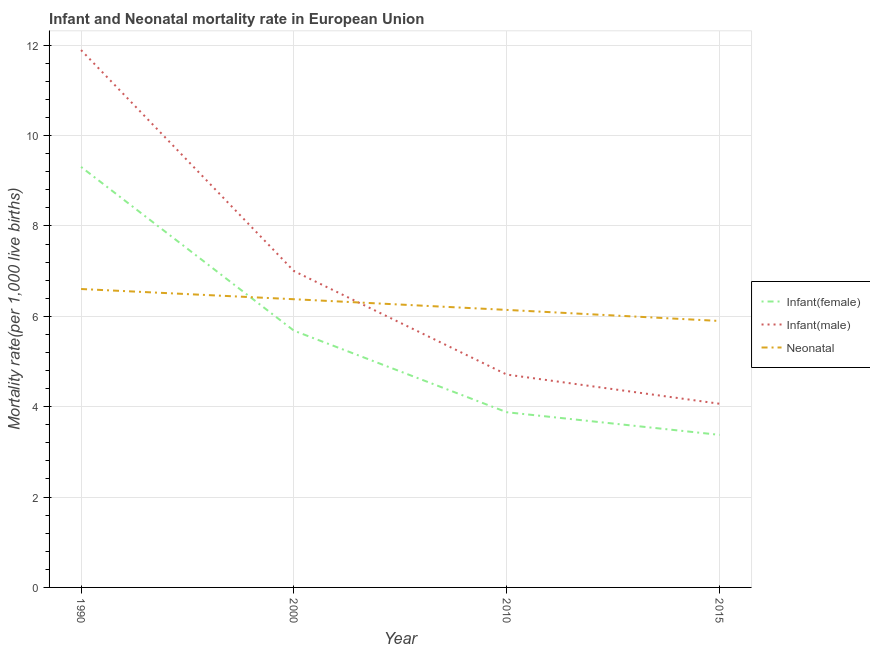Does the line corresponding to infant mortality rate(female) intersect with the line corresponding to neonatal mortality rate?
Offer a very short reply. Yes. Is the number of lines equal to the number of legend labels?
Keep it short and to the point. Yes. What is the neonatal mortality rate in 2015?
Your answer should be very brief. 5.9. Across all years, what is the maximum infant mortality rate(male)?
Your response must be concise. 11.89. Across all years, what is the minimum infant mortality rate(female)?
Offer a very short reply. 3.38. In which year was the infant mortality rate(male) minimum?
Offer a terse response. 2015. What is the total infant mortality rate(male) in the graph?
Ensure brevity in your answer.  27.67. What is the difference between the infant mortality rate(female) in 1990 and that in 2010?
Your answer should be compact. 5.43. What is the difference between the neonatal mortality rate in 2015 and the infant mortality rate(female) in 1990?
Your answer should be compact. -3.41. What is the average infant mortality rate(male) per year?
Give a very brief answer. 6.92. In the year 2000, what is the difference between the neonatal mortality rate and infant mortality rate(male)?
Ensure brevity in your answer.  -0.62. In how many years, is the neonatal mortality rate greater than 2.8?
Offer a terse response. 4. What is the ratio of the infant mortality rate(male) in 2010 to that in 2015?
Your response must be concise. 1.16. Is the difference between the infant mortality rate(male) in 2010 and 2015 greater than the difference between the infant mortality rate(female) in 2010 and 2015?
Your answer should be compact. Yes. What is the difference between the highest and the second highest infant mortality rate(male)?
Keep it short and to the point. 4.89. What is the difference between the highest and the lowest neonatal mortality rate?
Your answer should be compact. 0.71. Is the sum of the neonatal mortality rate in 2000 and 2010 greater than the maximum infant mortality rate(male) across all years?
Offer a very short reply. Yes. Does the infant mortality rate(male) monotonically increase over the years?
Offer a terse response. No. How many lines are there?
Make the answer very short. 3. How many years are there in the graph?
Give a very brief answer. 4. Does the graph contain any zero values?
Provide a succinct answer. No. Where does the legend appear in the graph?
Your answer should be very brief. Center right. How many legend labels are there?
Offer a terse response. 3. What is the title of the graph?
Your answer should be compact. Infant and Neonatal mortality rate in European Union. What is the label or title of the X-axis?
Ensure brevity in your answer.  Year. What is the label or title of the Y-axis?
Your answer should be very brief. Mortality rate(per 1,0 live births). What is the Mortality rate(per 1,000 live births) in Infant(female) in 1990?
Your answer should be compact. 9.31. What is the Mortality rate(per 1,000 live births) in Infant(male) in 1990?
Your answer should be very brief. 11.89. What is the Mortality rate(per 1,000 live births) in Neonatal  in 1990?
Make the answer very short. 6.6. What is the Mortality rate(per 1,000 live births) in Infant(female) in 2000?
Your response must be concise. 5.68. What is the Mortality rate(per 1,000 live births) of Infant(male) in 2000?
Offer a very short reply. 7. What is the Mortality rate(per 1,000 live births) in Neonatal  in 2000?
Ensure brevity in your answer.  6.38. What is the Mortality rate(per 1,000 live births) in Infant(female) in 2010?
Offer a very short reply. 3.88. What is the Mortality rate(per 1,000 live births) of Infant(male) in 2010?
Keep it short and to the point. 4.71. What is the Mortality rate(per 1,000 live births) of Neonatal  in 2010?
Ensure brevity in your answer.  6.14. What is the Mortality rate(per 1,000 live births) of Infant(female) in 2015?
Ensure brevity in your answer.  3.38. What is the Mortality rate(per 1,000 live births) of Infant(male) in 2015?
Offer a very short reply. 4.07. What is the Mortality rate(per 1,000 live births) in Neonatal  in 2015?
Ensure brevity in your answer.  5.9. Across all years, what is the maximum Mortality rate(per 1,000 live births) in Infant(female)?
Provide a short and direct response. 9.31. Across all years, what is the maximum Mortality rate(per 1,000 live births) in Infant(male)?
Give a very brief answer. 11.89. Across all years, what is the maximum Mortality rate(per 1,000 live births) of Neonatal ?
Offer a terse response. 6.6. Across all years, what is the minimum Mortality rate(per 1,000 live births) of Infant(female)?
Your answer should be compact. 3.38. Across all years, what is the minimum Mortality rate(per 1,000 live births) in Infant(male)?
Make the answer very short. 4.07. Across all years, what is the minimum Mortality rate(per 1,000 live births) of Neonatal ?
Offer a very short reply. 5.9. What is the total Mortality rate(per 1,000 live births) in Infant(female) in the graph?
Make the answer very short. 22.24. What is the total Mortality rate(per 1,000 live births) of Infant(male) in the graph?
Ensure brevity in your answer.  27.67. What is the total Mortality rate(per 1,000 live births) of Neonatal  in the graph?
Give a very brief answer. 25.02. What is the difference between the Mortality rate(per 1,000 live births) of Infant(female) in 1990 and that in 2000?
Your response must be concise. 3.62. What is the difference between the Mortality rate(per 1,000 live births) in Infant(male) in 1990 and that in 2000?
Your answer should be very brief. 4.89. What is the difference between the Mortality rate(per 1,000 live births) in Neonatal  in 1990 and that in 2000?
Offer a terse response. 0.23. What is the difference between the Mortality rate(per 1,000 live births) of Infant(female) in 1990 and that in 2010?
Give a very brief answer. 5.43. What is the difference between the Mortality rate(per 1,000 live births) in Infant(male) in 1990 and that in 2010?
Keep it short and to the point. 7.18. What is the difference between the Mortality rate(per 1,000 live births) in Neonatal  in 1990 and that in 2010?
Your answer should be compact. 0.46. What is the difference between the Mortality rate(per 1,000 live births) of Infant(female) in 1990 and that in 2015?
Your answer should be very brief. 5.93. What is the difference between the Mortality rate(per 1,000 live births) in Infant(male) in 1990 and that in 2015?
Give a very brief answer. 7.83. What is the difference between the Mortality rate(per 1,000 live births) in Neonatal  in 1990 and that in 2015?
Give a very brief answer. 0.71. What is the difference between the Mortality rate(per 1,000 live births) of Infant(female) in 2000 and that in 2010?
Keep it short and to the point. 1.81. What is the difference between the Mortality rate(per 1,000 live births) of Infant(male) in 2000 and that in 2010?
Make the answer very short. 2.29. What is the difference between the Mortality rate(per 1,000 live births) in Neonatal  in 2000 and that in 2010?
Provide a short and direct response. 0.24. What is the difference between the Mortality rate(per 1,000 live births) of Infant(female) in 2000 and that in 2015?
Give a very brief answer. 2.31. What is the difference between the Mortality rate(per 1,000 live births) of Infant(male) in 2000 and that in 2015?
Provide a succinct answer. 2.94. What is the difference between the Mortality rate(per 1,000 live births) in Neonatal  in 2000 and that in 2015?
Give a very brief answer. 0.48. What is the difference between the Mortality rate(per 1,000 live births) in Infant(female) in 2010 and that in 2015?
Keep it short and to the point. 0.5. What is the difference between the Mortality rate(per 1,000 live births) of Infant(male) in 2010 and that in 2015?
Provide a succinct answer. 0.65. What is the difference between the Mortality rate(per 1,000 live births) of Neonatal  in 2010 and that in 2015?
Offer a very short reply. 0.24. What is the difference between the Mortality rate(per 1,000 live births) in Infant(female) in 1990 and the Mortality rate(per 1,000 live births) in Infant(male) in 2000?
Your answer should be very brief. 2.3. What is the difference between the Mortality rate(per 1,000 live births) in Infant(female) in 1990 and the Mortality rate(per 1,000 live births) in Neonatal  in 2000?
Keep it short and to the point. 2.93. What is the difference between the Mortality rate(per 1,000 live births) of Infant(male) in 1990 and the Mortality rate(per 1,000 live births) of Neonatal  in 2000?
Provide a succinct answer. 5.51. What is the difference between the Mortality rate(per 1,000 live births) of Infant(female) in 1990 and the Mortality rate(per 1,000 live births) of Infant(male) in 2010?
Provide a short and direct response. 4.6. What is the difference between the Mortality rate(per 1,000 live births) of Infant(female) in 1990 and the Mortality rate(per 1,000 live births) of Neonatal  in 2010?
Your response must be concise. 3.16. What is the difference between the Mortality rate(per 1,000 live births) of Infant(male) in 1990 and the Mortality rate(per 1,000 live births) of Neonatal  in 2010?
Your answer should be compact. 5.75. What is the difference between the Mortality rate(per 1,000 live births) of Infant(female) in 1990 and the Mortality rate(per 1,000 live births) of Infant(male) in 2015?
Provide a succinct answer. 5.24. What is the difference between the Mortality rate(per 1,000 live births) of Infant(female) in 1990 and the Mortality rate(per 1,000 live births) of Neonatal  in 2015?
Offer a terse response. 3.41. What is the difference between the Mortality rate(per 1,000 live births) of Infant(male) in 1990 and the Mortality rate(per 1,000 live births) of Neonatal  in 2015?
Provide a succinct answer. 6. What is the difference between the Mortality rate(per 1,000 live births) of Infant(female) in 2000 and the Mortality rate(per 1,000 live births) of Infant(male) in 2010?
Your answer should be very brief. 0.97. What is the difference between the Mortality rate(per 1,000 live births) in Infant(female) in 2000 and the Mortality rate(per 1,000 live births) in Neonatal  in 2010?
Offer a terse response. -0.46. What is the difference between the Mortality rate(per 1,000 live births) in Infant(male) in 2000 and the Mortality rate(per 1,000 live births) in Neonatal  in 2010?
Your response must be concise. 0.86. What is the difference between the Mortality rate(per 1,000 live births) in Infant(female) in 2000 and the Mortality rate(per 1,000 live births) in Infant(male) in 2015?
Offer a terse response. 1.62. What is the difference between the Mortality rate(per 1,000 live births) of Infant(female) in 2000 and the Mortality rate(per 1,000 live births) of Neonatal  in 2015?
Your answer should be very brief. -0.21. What is the difference between the Mortality rate(per 1,000 live births) in Infant(male) in 2000 and the Mortality rate(per 1,000 live births) in Neonatal  in 2015?
Give a very brief answer. 1.1. What is the difference between the Mortality rate(per 1,000 live births) of Infant(female) in 2010 and the Mortality rate(per 1,000 live births) of Infant(male) in 2015?
Offer a terse response. -0.19. What is the difference between the Mortality rate(per 1,000 live births) of Infant(female) in 2010 and the Mortality rate(per 1,000 live births) of Neonatal  in 2015?
Make the answer very short. -2.02. What is the difference between the Mortality rate(per 1,000 live births) of Infant(male) in 2010 and the Mortality rate(per 1,000 live births) of Neonatal  in 2015?
Ensure brevity in your answer.  -1.19. What is the average Mortality rate(per 1,000 live births) in Infant(female) per year?
Provide a short and direct response. 5.56. What is the average Mortality rate(per 1,000 live births) of Infant(male) per year?
Your response must be concise. 6.92. What is the average Mortality rate(per 1,000 live births) in Neonatal  per year?
Provide a short and direct response. 6.26. In the year 1990, what is the difference between the Mortality rate(per 1,000 live births) of Infant(female) and Mortality rate(per 1,000 live births) of Infant(male)?
Offer a terse response. -2.59. In the year 1990, what is the difference between the Mortality rate(per 1,000 live births) of Infant(female) and Mortality rate(per 1,000 live births) of Neonatal ?
Your answer should be very brief. 2.7. In the year 1990, what is the difference between the Mortality rate(per 1,000 live births) in Infant(male) and Mortality rate(per 1,000 live births) in Neonatal ?
Ensure brevity in your answer.  5.29. In the year 2000, what is the difference between the Mortality rate(per 1,000 live births) in Infant(female) and Mortality rate(per 1,000 live births) in Infant(male)?
Make the answer very short. -1.32. In the year 2000, what is the difference between the Mortality rate(per 1,000 live births) in Infant(female) and Mortality rate(per 1,000 live births) in Neonatal ?
Provide a short and direct response. -0.7. In the year 2000, what is the difference between the Mortality rate(per 1,000 live births) of Infant(male) and Mortality rate(per 1,000 live births) of Neonatal ?
Make the answer very short. 0.62. In the year 2010, what is the difference between the Mortality rate(per 1,000 live births) of Infant(female) and Mortality rate(per 1,000 live births) of Infant(male)?
Keep it short and to the point. -0.83. In the year 2010, what is the difference between the Mortality rate(per 1,000 live births) in Infant(female) and Mortality rate(per 1,000 live births) in Neonatal ?
Provide a succinct answer. -2.26. In the year 2010, what is the difference between the Mortality rate(per 1,000 live births) of Infant(male) and Mortality rate(per 1,000 live births) of Neonatal ?
Keep it short and to the point. -1.43. In the year 2015, what is the difference between the Mortality rate(per 1,000 live births) in Infant(female) and Mortality rate(per 1,000 live births) in Infant(male)?
Provide a succinct answer. -0.69. In the year 2015, what is the difference between the Mortality rate(per 1,000 live births) of Infant(female) and Mortality rate(per 1,000 live births) of Neonatal ?
Offer a very short reply. -2.52. In the year 2015, what is the difference between the Mortality rate(per 1,000 live births) of Infant(male) and Mortality rate(per 1,000 live births) of Neonatal ?
Your answer should be very brief. -1.83. What is the ratio of the Mortality rate(per 1,000 live births) of Infant(female) in 1990 to that in 2000?
Your answer should be compact. 1.64. What is the ratio of the Mortality rate(per 1,000 live births) in Infant(male) in 1990 to that in 2000?
Your answer should be compact. 1.7. What is the ratio of the Mortality rate(per 1,000 live births) of Neonatal  in 1990 to that in 2000?
Your response must be concise. 1.04. What is the ratio of the Mortality rate(per 1,000 live births) of Infant(female) in 1990 to that in 2010?
Ensure brevity in your answer.  2.4. What is the ratio of the Mortality rate(per 1,000 live births) of Infant(male) in 1990 to that in 2010?
Offer a very short reply. 2.52. What is the ratio of the Mortality rate(per 1,000 live births) in Neonatal  in 1990 to that in 2010?
Provide a short and direct response. 1.08. What is the ratio of the Mortality rate(per 1,000 live births) of Infant(female) in 1990 to that in 2015?
Your response must be concise. 2.76. What is the ratio of the Mortality rate(per 1,000 live births) of Infant(male) in 1990 to that in 2015?
Provide a short and direct response. 2.93. What is the ratio of the Mortality rate(per 1,000 live births) of Neonatal  in 1990 to that in 2015?
Provide a short and direct response. 1.12. What is the ratio of the Mortality rate(per 1,000 live births) of Infant(female) in 2000 to that in 2010?
Provide a succinct answer. 1.47. What is the ratio of the Mortality rate(per 1,000 live births) of Infant(male) in 2000 to that in 2010?
Offer a very short reply. 1.49. What is the ratio of the Mortality rate(per 1,000 live births) in Neonatal  in 2000 to that in 2010?
Your answer should be compact. 1.04. What is the ratio of the Mortality rate(per 1,000 live births) of Infant(female) in 2000 to that in 2015?
Your response must be concise. 1.68. What is the ratio of the Mortality rate(per 1,000 live births) of Infant(male) in 2000 to that in 2015?
Offer a very short reply. 1.72. What is the ratio of the Mortality rate(per 1,000 live births) in Neonatal  in 2000 to that in 2015?
Provide a succinct answer. 1.08. What is the ratio of the Mortality rate(per 1,000 live births) in Infant(female) in 2010 to that in 2015?
Provide a short and direct response. 1.15. What is the ratio of the Mortality rate(per 1,000 live births) of Infant(male) in 2010 to that in 2015?
Offer a very short reply. 1.16. What is the ratio of the Mortality rate(per 1,000 live births) of Neonatal  in 2010 to that in 2015?
Your answer should be very brief. 1.04. What is the difference between the highest and the second highest Mortality rate(per 1,000 live births) of Infant(female)?
Provide a succinct answer. 3.62. What is the difference between the highest and the second highest Mortality rate(per 1,000 live births) of Infant(male)?
Keep it short and to the point. 4.89. What is the difference between the highest and the second highest Mortality rate(per 1,000 live births) in Neonatal ?
Your response must be concise. 0.23. What is the difference between the highest and the lowest Mortality rate(per 1,000 live births) in Infant(female)?
Offer a terse response. 5.93. What is the difference between the highest and the lowest Mortality rate(per 1,000 live births) in Infant(male)?
Your answer should be compact. 7.83. What is the difference between the highest and the lowest Mortality rate(per 1,000 live births) of Neonatal ?
Offer a very short reply. 0.71. 